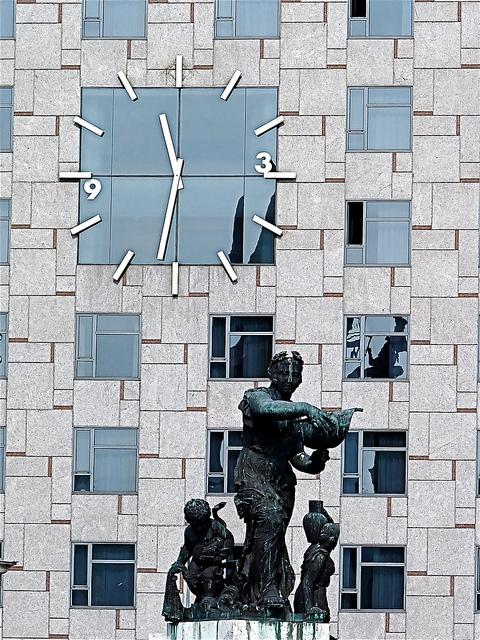How many clock faces are there?
Keep it brief. 1. What is the clock for?
Answer briefly. Telling time. What time is on the clock?
Answer briefly. 11:32. 